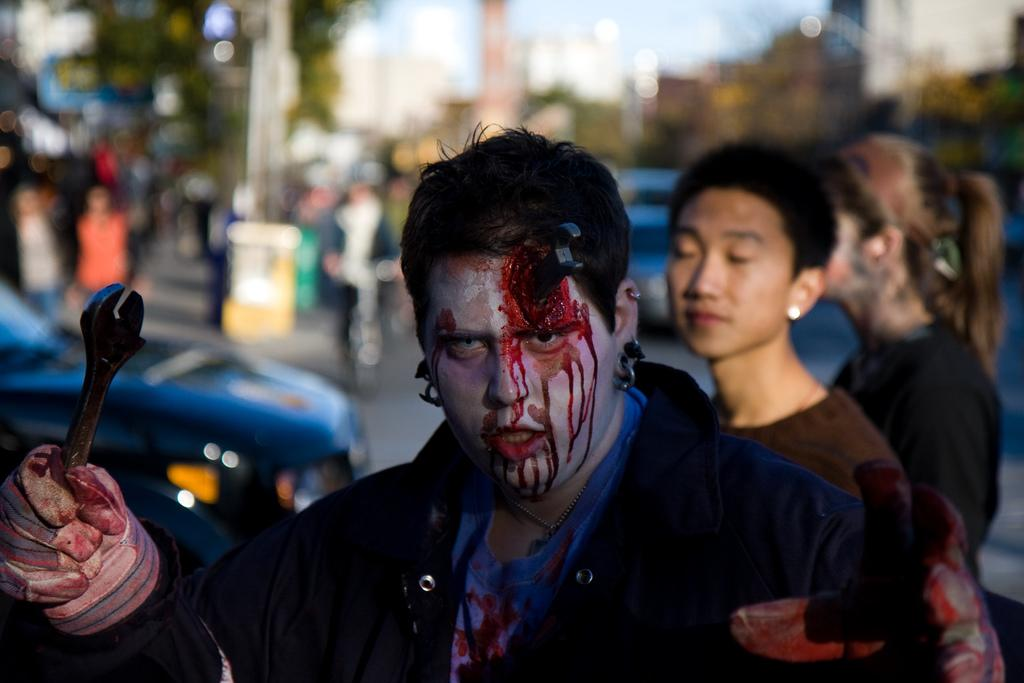How many people are in the image? There are people in the image, but the exact number is not specified. What is the condition of one of the people in the image? One person has blood. What is the person with blood holding? The person with blood is holding an object. What type of transportation can be seen in the image? There are vehicles in the image. Can you describe the background of the image? The background of the image is blurred. How many children are playing with the car in the image? There is no car or children present in the image. What is the height of the low-hanging tree in the image? There is no tree mentioned in the image, so it is impossible to determine the height of a low-hanging tree. 